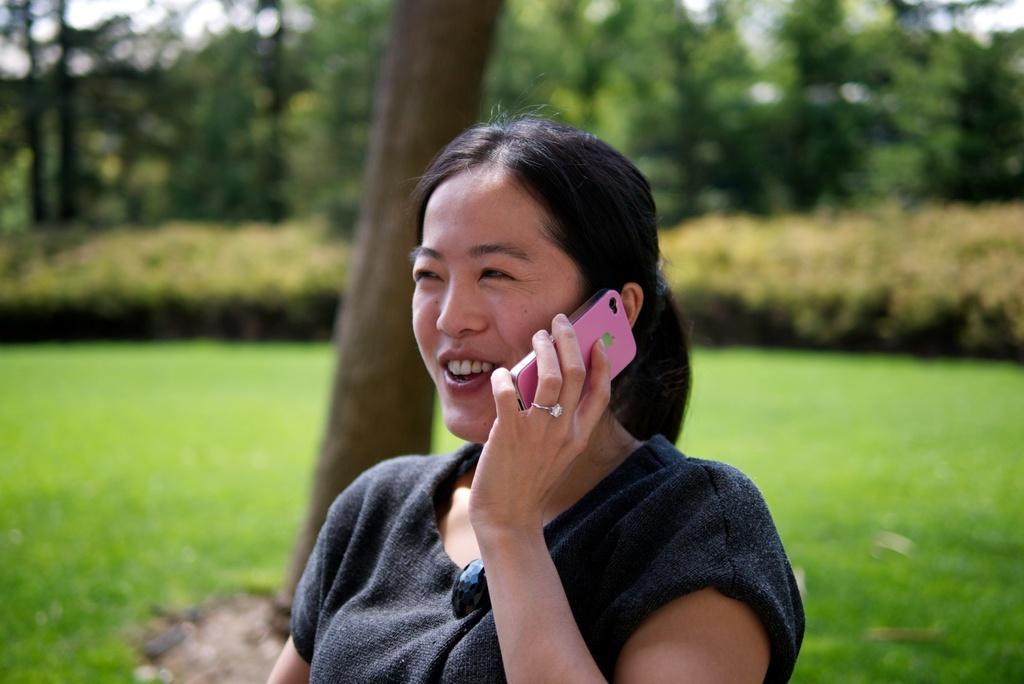Who is present in the image? There is a woman in the image. What is the woman doing in the image? The woman is speaking on a mobile phone. What can be seen in the background of the image? There are trees and plants visible in the background of the image. What type of iron is the woman using in the image? There is no iron present in the image; the woman is speaking on a mobile phone. Can you see a yak in the image? There is no yak present in the image; the background features trees and plants. 